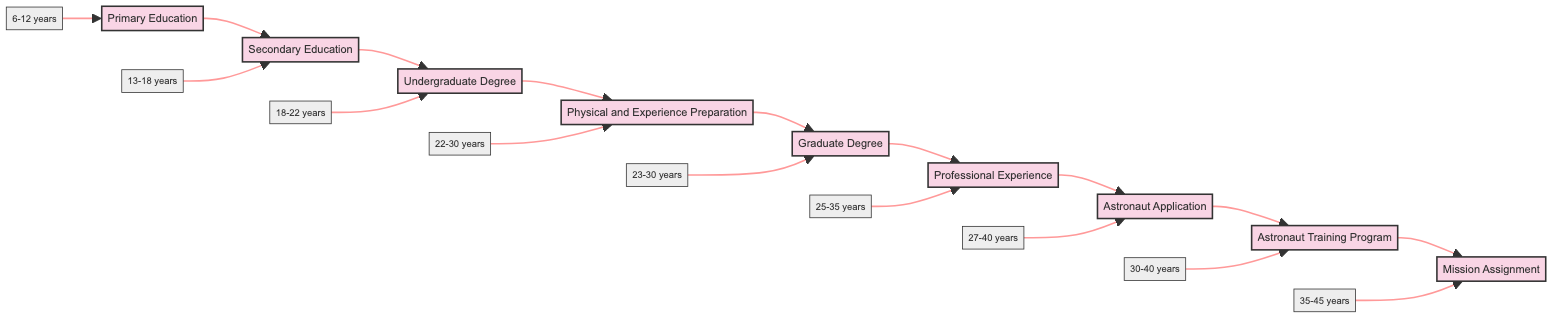What is the first stage in the pathway to becoming an astronaut? The diagram starts with "Primary Education," indicating this is the first stage in the process.
Answer: Primary Education What age range corresponds to the "Undergraduate Degree" stage? The diagram shows "Undergraduate Degree" with an age range of "18-22 years," which provides the specific time frame for this stage.
Answer: 18-22 years Which institutions are listed for "Physical and Experience Preparation"? Looking at the node for "Physical and Experience Preparation," I can see it mentions "Peruvian Air Force" and "NASA Internships" as the institutions linked to this stage.
Answer: Peruvian Air Force, NASA Internships How many total stages are included in this flowchart? By counting the nodes in the diagram, there are nine distinct stages of the astronaut pathway.
Answer: 9 What comes after "Graduate Degree"? In the sequence of nodes, "Professional Experience" directly follows "Graduate Degree," indicating what stage comes next in the process.
Answer: Professional Experience What is the age range for the "Astronaut Application" stage? The age mentioned for "Astronaut Application" in the diagram is "27-40 years," which provides the applicable age range for this stage.
Answer: 27-40 years Which stage includes maintaining physical fitness? "Physical and Experience Preparation" is explicitly described in the stage details to include maintaining physical fitness, highlighting its essential requirement.
Answer: Physical and Experience Preparation What is the last stage before receiving a mission assignment? The diagram specifies that the stage immediately preceding "Mission Assignment" is "Astronaut Training Program," indicating the last preparatory step before assignments.
Answer: Astronaut Training Program At what age does one typically start the "Secondary Education"? The "Secondary Education" stage indicates an age range of "13-18 years," showing the starting age typically associated with this educational stage.
Answer: 13-18 years 